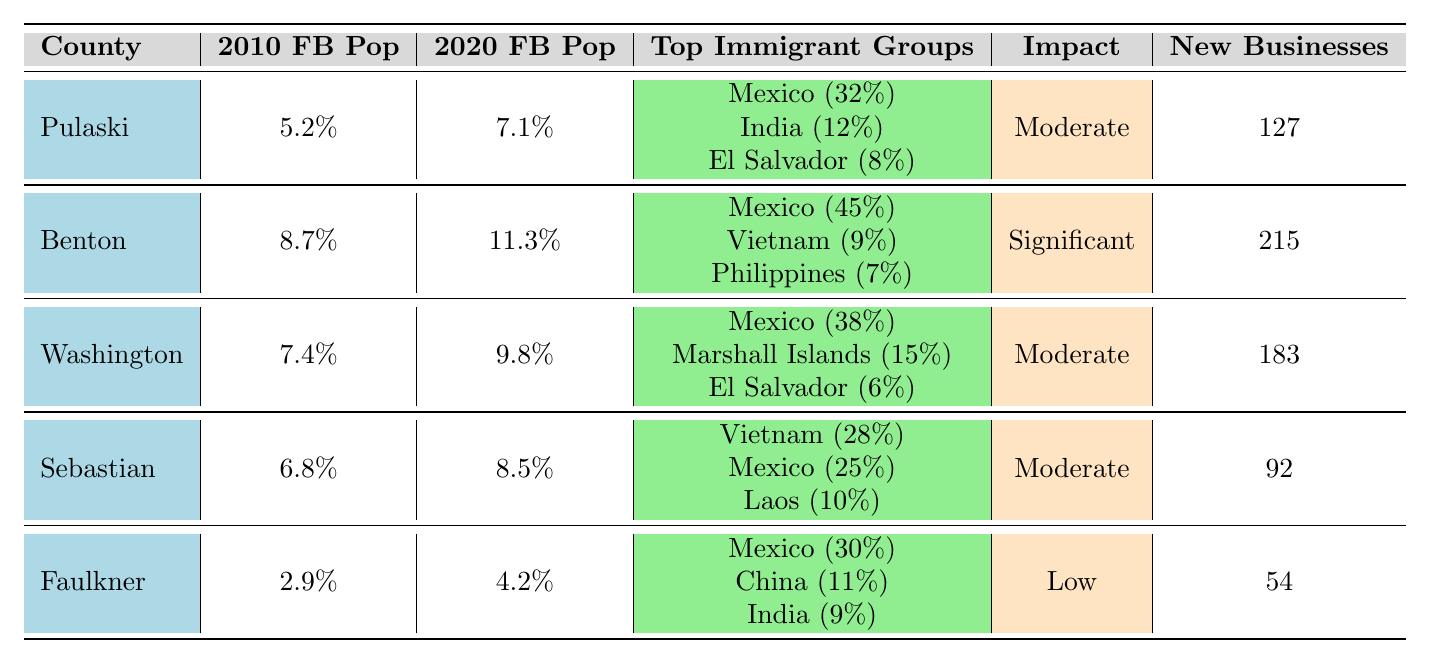What is the foreign-born population percentage in Benton County for 2020? Benton County's foreign-born population for 2020 is listed as 11.3% in the table.
Answer: 11.3% Which county has the highest percentage of foreign-born population in 2020? By comparing the 2020 percentages, Benton County has the highest at 11.3% among all listed counties.
Answer: Benton County How many new businesses were opened by immigrants in Pulaski County? The table shows that immigrants opened 127 new businesses in Pulaski County.
Answer: 127 Which county experienced the smallest increase in foreign-born population percentage from 2010 to 2020? The increase for each county is calculated as follows: Pulaski (1.9%), Benton (2.6%), Washington (2.4%), Sebastian (1.7%), and Faulkner (1.3%). Faulkner had the smallest increase at 1.3%.
Answer: Faulkner County What is the overall impact on local traditions in Sebastian County based on the data? The table specifies that the impact on local traditions in Sebastian County is categorized as 'Moderate'.
Answer: Moderate Which two counties have the same impact level on local traditions? Pulaski, Washington, and Sebastian have a 'Moderate' impact, while Benton has 'Significant' and Faulkner has 'Low'. Thus, Pulaski, Washington, and Sebastian share the same impact level.
Answer: Pulaski and Washington, Sebastian What is the total number of new businesses opened by immigrants across all listed counties? The total number of new businesses is calculated by adding the values: 127 (Pulaski) + 215 (Benton) + 183 (Washington) + 92 (Sebastian) + 54 (Faulkner) = 671.
Answer: 671 Which country contributes the largest percentage of immigrants in Benton County? According to the table, Mexico contributes 45% of the immigrant population in Benton County, which is the largest percentage.
Answer: Mexico What percentage of the immigrant population in Faulkner County comes from China? The table shows that 11% of the immigrant population in Faulkner County comes from China.
Answer: 11% If you combine the percentages of the top three immigrant groups in Washington County, what is the total? The top three groups in Washington are Mexico (38%), Marshall Islands (15%), and El Salvador (6%). Adding these gives 38 + 15 + 6 = 59%.
Answer: 59% 